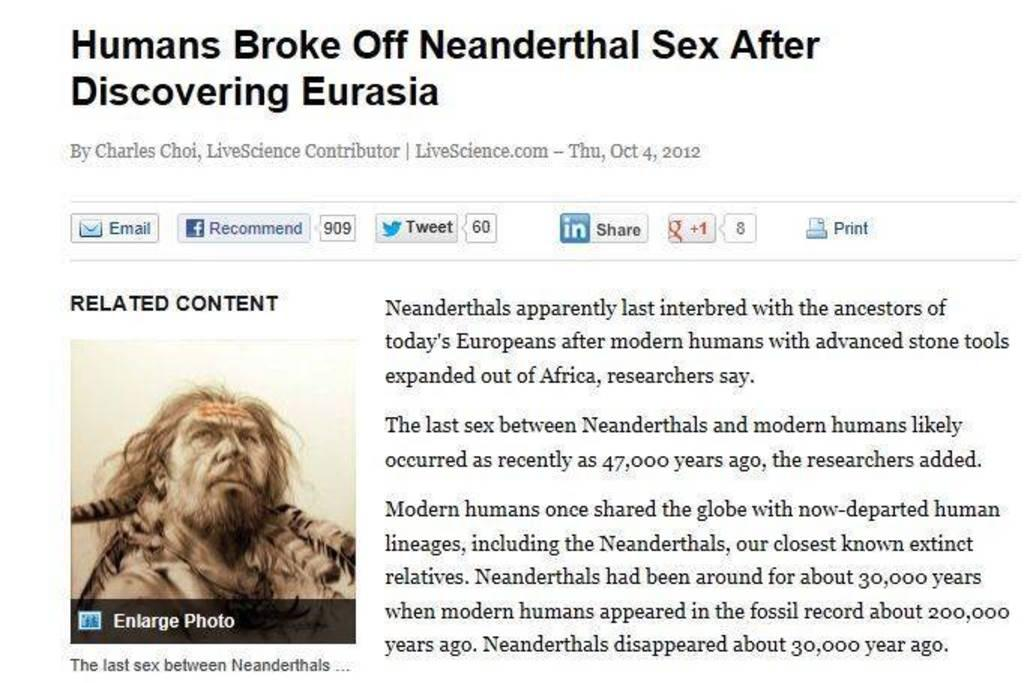What type of content is the image displaying? The image is a post. Is there any specific section or heading on the post? Yes, there is a side heading on the post. What can be found on the post besides the side heading? There are texts written on the post. Is there any visual element on the post? Yes, there is a picture of a person on the left side of the post. What date is circled on the calendar in the image? There is no calendar present in the image; it only contains a post with a side heading, texts, and a picture of a person. 